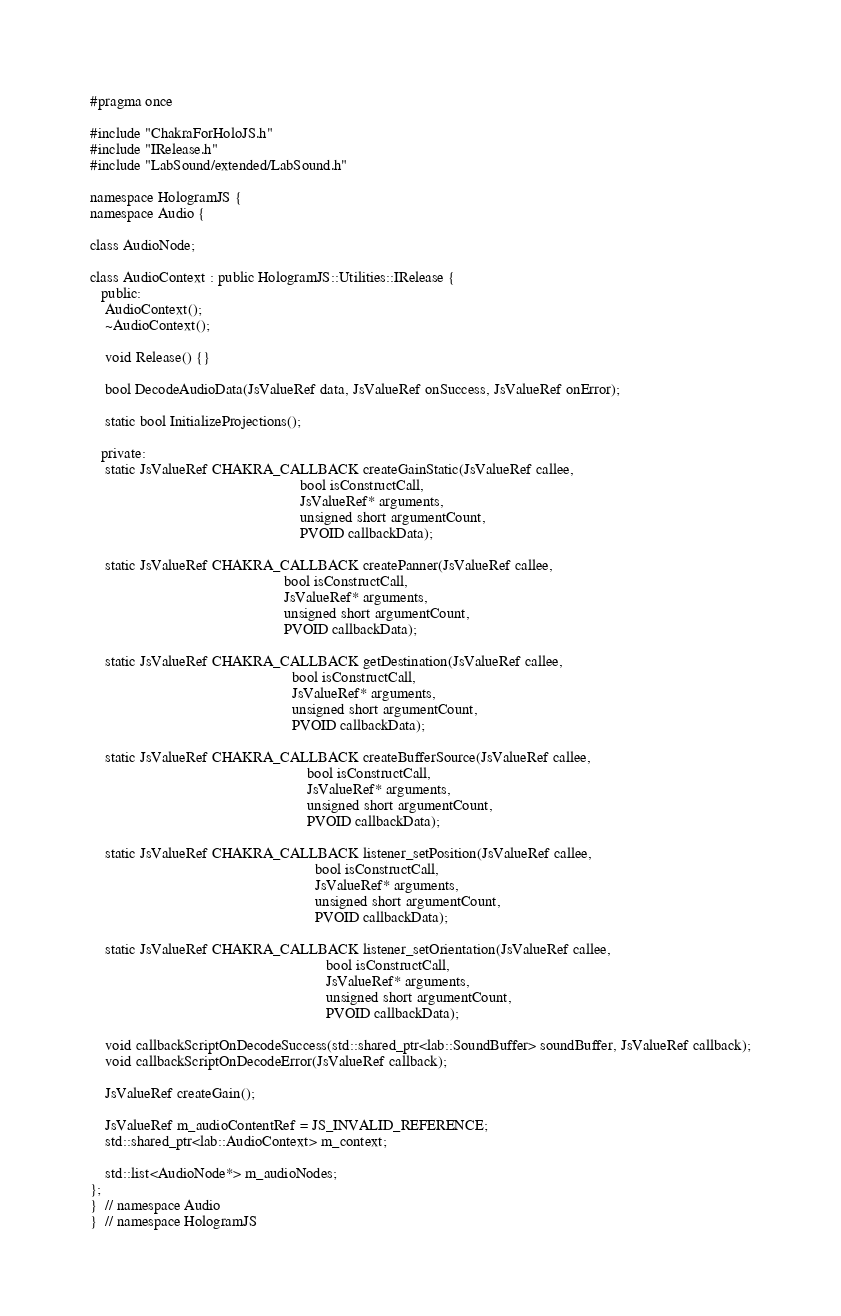<code> <loc_0><loc_0><loc_500><loc_500><_C_>#pragma once

#include "ChakraForHoloJS.h"
#include "IRelease.h"
#include "LabSound/extended/LabSound.h"

namespace HologramJS {
namespace Audio {

class AudioNode;

class AudioContext : public HologramJS::Utilities::IRelease {
   public:
    AudioContext();
    ~AudioContext();

    void Release() {}

    bool DecodeAudioData(JsValueRef data, JsValueRef onSuccess, JsValueRef onError);

    static bool InitializeProjections();

   private:
    static JsValueRef CHAKRA_CALLBACK createGainStatic(JsValueRef callee,
                                                       bool isConstructCall,
                                                       JsValueRef* arguments,
                                                       unsigned short argumentCount,
                                                       PVOID callbackData);

    static JsValueRef CHAKRA_CALLBACK createPanner(JsValueRef callee,
                                                   bool isConstructCall,
                                                   JsValueRef* arguments,
                                                   unsigned short argumentCount,
                                                   PVOID callbackData);

    static JsValueRef CHAKRA_CALLBACK getDestination(JsValueRef callee,
                                                     bool isConstructCall,
                                                     JsValueRef* arguments,
                                                     unsigned short argumentCount,
                                                     PVOID callbackData);

    static JsValueRef CHAKRA_CALLBACK createBufferSource(JsValueRef callee,
                                                         bool isConstructCall,
                                                         JsValueRef* arguments,
                                                         unsigned short argumentCount,
                                                         PVOID callbackData);

    static JsValueRef CHAKRA_CALLBACK listener_setPosition(JsValueRef callee,
                                                           bool isConstructCall,
                                                           JsValueRef* arguments,
                                                           unsigned short argumentCount,
                                                           PVOID callbackData);

    static JsValueRef CHAKRA_CALLBACK listener_setOrientation(JsValueRef callee,
                                                              bool isConstructCall,
                                                              JsValueRef* arguments,
                                                              unsigned short argumentCount,
                                                              PVOID callbackData);

    void callbackScriptOnDecodeSuccess(std::shared_ptr<lab::SoundBuffer> soundBuffer, JsValueRef callback);
    void callbackScriptOnDecodeError(JsValueRef callback);

    JsValueRef createGain();

    JsValueRef m_audioContentRef = JS_INVALID_REFERENCE;
    std::shared_ptr<lab::AudioContext> m_context;

    std::list<AudioNode*> m_audioNodes;
};
}  // namespace Audio
}  // namespace HologramJS
</code> 